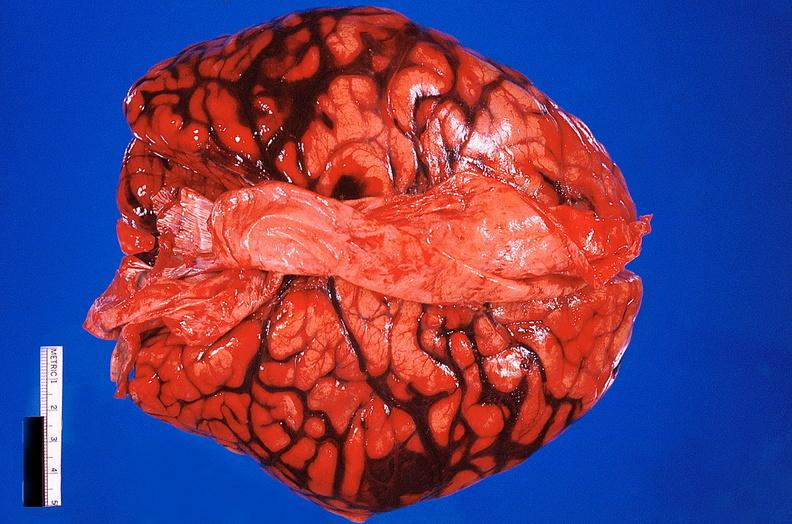s lesion present?
Answer the question using a single word or phrase. No 